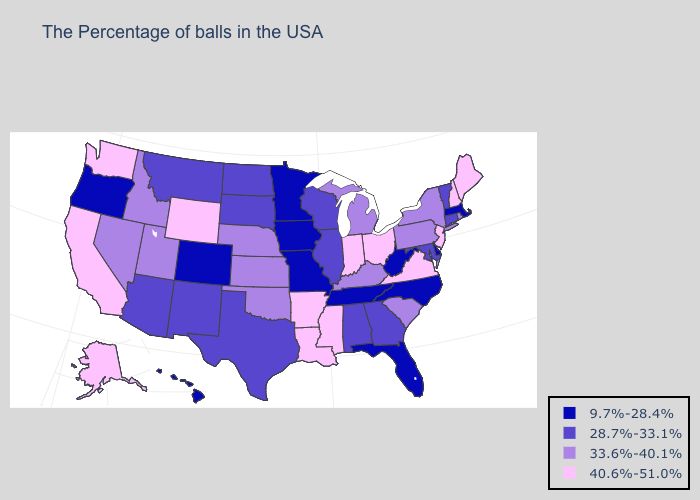Among the states that border New York , which have the highest value?
Give a very brief answer. New Jersey. Name the states that have a value in the range 9.7%-28.4%?
Quick response, please. Massachusetts, Delaware, North Carolina, West Virginia, Florida, Tennessee, Missouri, Minnesota, Iowa, Colorado, Oregon, Hawaii. Does the map have missing data?
Quick response, please. No. Does Indiana have a higher value than Arkansas?
Quick response, please. No. Does Illinois have a higher value than Florida?
Keep it brief. Yes. What is the highest value in the USA?
Answer briefly. 40.6%-51.0%. Does Missouri have the lowest value in the USA?
Concise answer only. Yes. What is the value of West Virginia?
Answer briefly. 9.7%-28.4%. Which states have the lowest value in the South?
Answer briefly. Delaware, North Carolina, West Virginia, Florida, Tennessee. Does the map have missing data?
Quick response, please. No. Does the first symbol in the legend represent the smallest category?
Concise answer only. Yes. What is the lowest value in the MidWest?
Keep it brief. 9.7%-28.4%. What is the value of Maine?
Keep it brief. 40.6%-51.0%. Among the states that border Arizona , which have the lowest value?
Short answer required. Colorado. Does Washington have the highest value in the USA?
Give a very brief answer. Yes. 